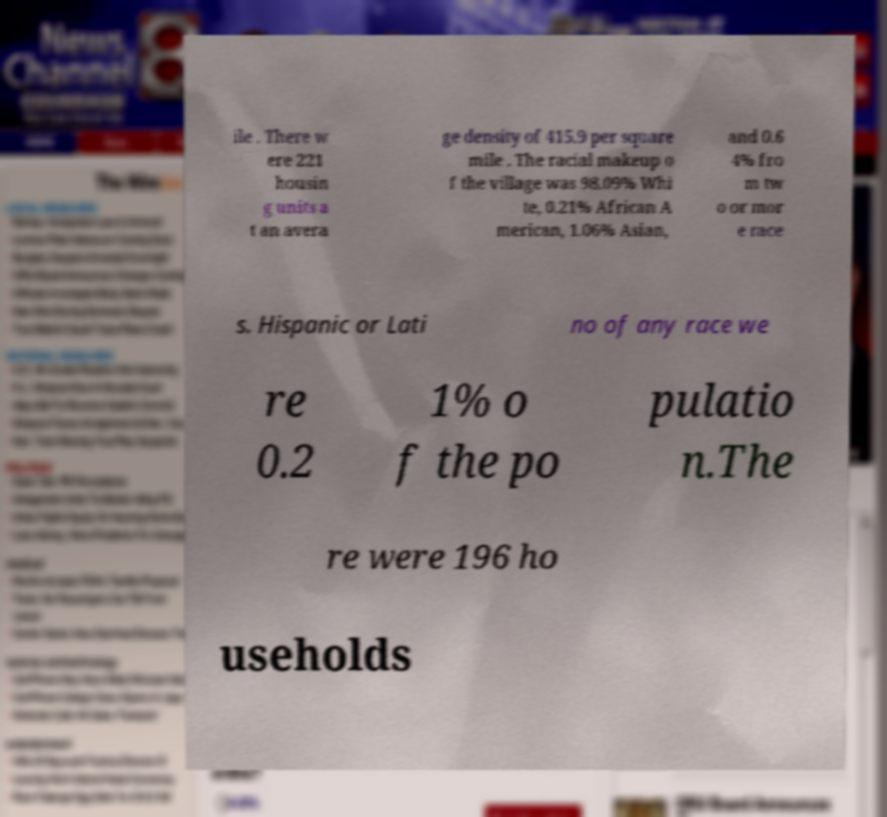Please read and relay the text visible in this image. What does it say? ile . There w ere 221 housin g units a t an avera ge density of 415.9 per square mile . The racial makeup o f the village was 98.09% Whi te, 0.21% African A merican, 1.06% Asian, and 0.6 4% fro m tw o or mor e race s. Hispanic or Lati no of any race we re 0.2 1% o f the po pulatio n.The re were 196 ho useholds 